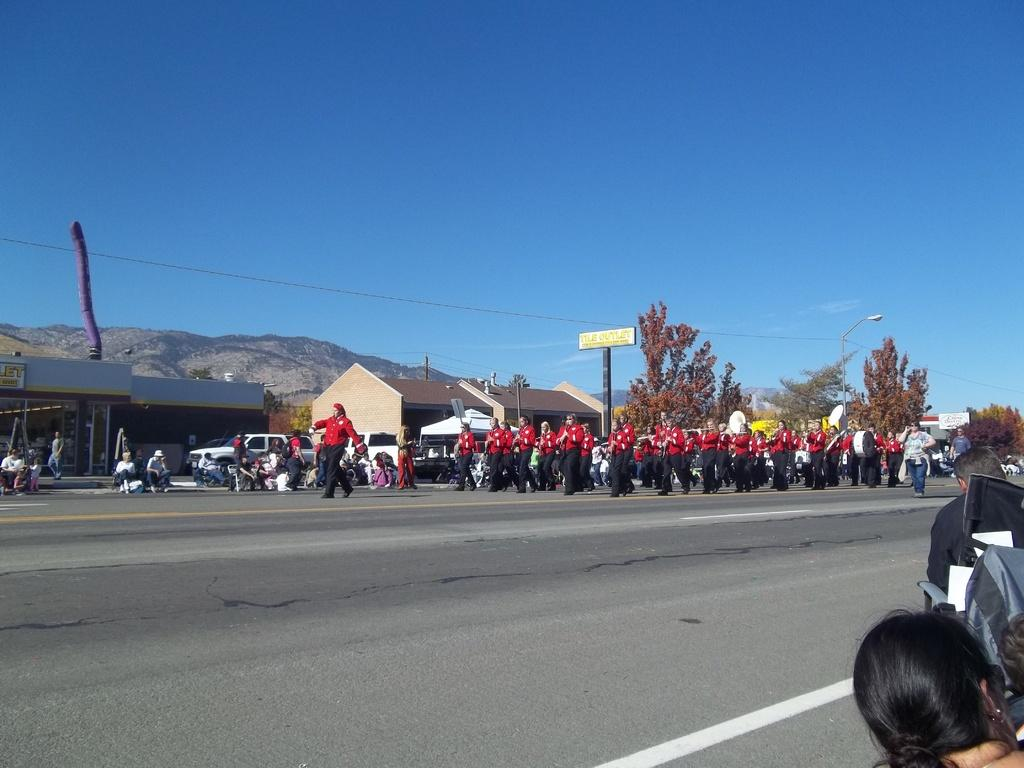What can be seen on the road in the image? There are persons on the road in the image. What type of natural elements are present in the image? There are trees in the image. What man-made structures can be seen in the image? There are poles, boards, and houses in the image. What type of transportation is visible in the image? There are vehicles in the image. What is visible in the background of the image? There is a mountain and the sky in the background of the image. Where is the garden located in the image? There is no garden present in the image. What type of pets can be seen in the image? There are no pets visible in the image. 